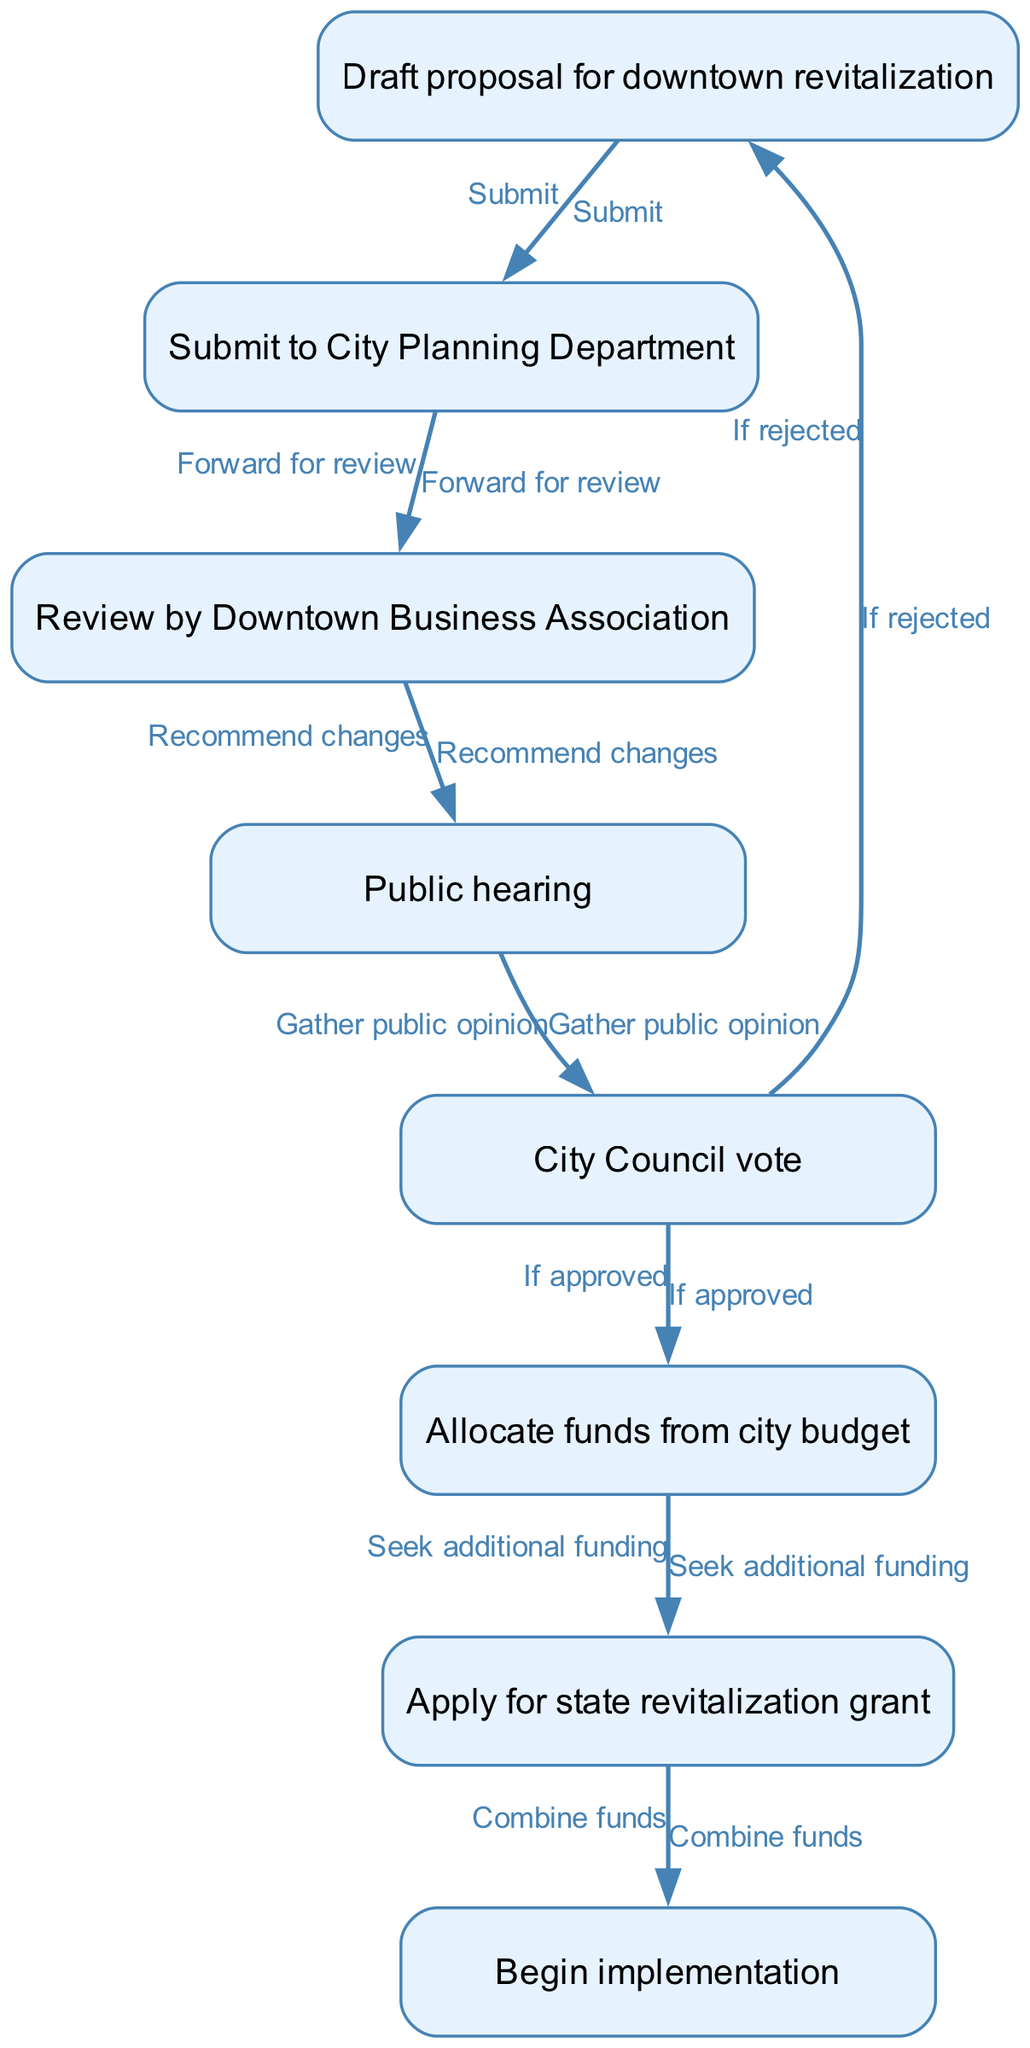What is the first step in the proposal process? The first step in the proposal process is to draft the proposal for downtown revitalization. This is indicated as the initial node in the flowchart labeled "Draft proposal for downtown revitalization."
Answer: Draft proposal for downtown revitalization How many nodes are in the diagram? By counting the elements in the "nodes" section of the data provided, there are a total of eight nodes representing various steps in the proposal process.
Answer: Eight What does the City Council do after the public hearing? After the public hearing, the next action is for the City Council to vote, as shown by the edge leading from the "Public hearing" node to the "City Council vote" node.
Answer: City Council vote If the proposal is rejected, what happens next? If the proposal is rejected, the flowchart indicates that the process returns to the "Draft proposal for downtown revitalization" step, as shown by the conditional edge labeled "If rejected."
Answer: Draft proposal for downtown revitalization What action follows the allocation of funds from the city budget? After the funds are allocated from the city budget, the next action is to apply for a state revitalization grant, as indicated by the directed edge to the "Apply for state revitalization grant" node.
Answer: Apply for state revitalization grant How many edges connect the nodes in the diagram? The "edges" section of the data lists eight connections, which represent the relationships and flow between the nodes, thus indicating there are eight edges in total.
Answer: Eight What is the relationship between the nodes "City Council vote" and "Allocate funds from city budget"? The relationship is conditional; after the City Council vote, if the proposal is approved, then funds will be allocated from the city budget, as indicated by the edge labeled "If approved."
Answer: Allocate funds from city budget What must be done before the start of implementation? Before beginning implementation, the flowchart requires combining funds obtained from the city budget and any state revitalization grant. This is shown as a necessary step following the grant application.
Answer: Combine funds 